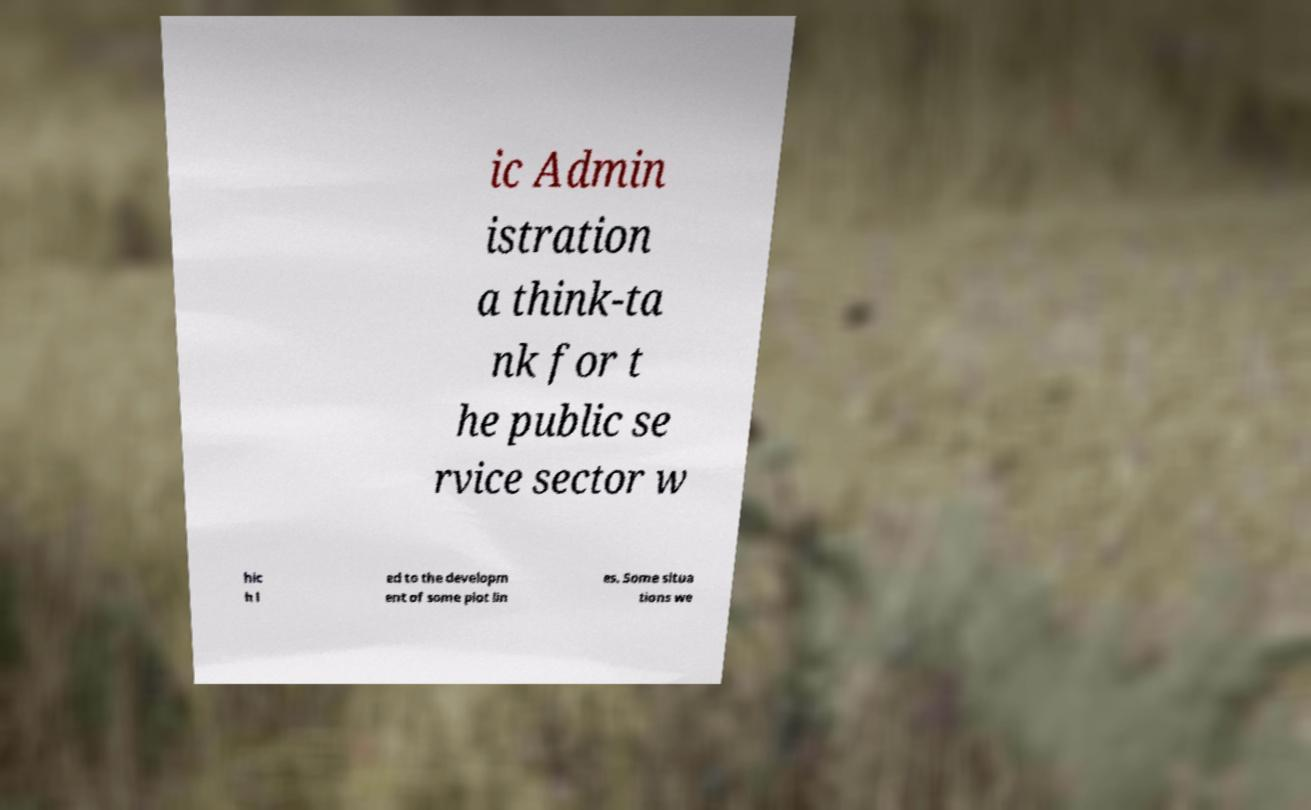Could you extract and type out the text from this image? ic Admin istration a think-ta nk for t he public se rvice sector w hic h l ed to the developm ent of some plot lin es. Some situa tions we 